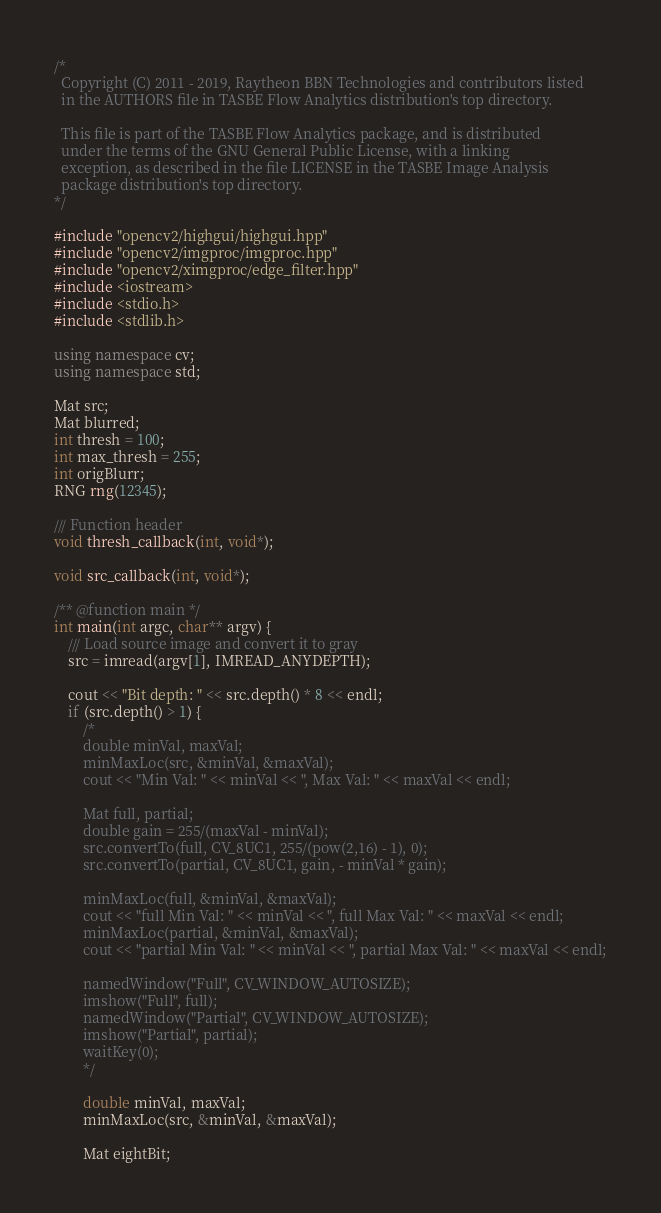<code> <loc_0><loc_0><loc_500><loc_500><_C++_>/*
  Copyright (C) 2011 - 2019, Raytheon BBN Technologies and contributors listed
  in the AUTHORS file in TASBE Flow Analytics distribution's top directory.

  This file is part of the TASBE Flow Analytics package, and is distributed
  under the terms of the GNU General Public License, with a linking
  exception, as described in the file LICENSE in the TASBE Image Analysis
  package distribution's top directory.
*/

#include "opencv2/highgui/highgui.hpp"
#include "opencv2/imgproc/imgproc.hpp"
#include "opencv2/ximgproc/edge_filter.hpp"
#include <iostream>
#include <stdio.h>
#include <stdlib.h>

using namespace cv;
using namespace std;

Mat src;
Mat blurred;
int thresh = 100;
int max_thresh = 255;
int origBlurr;
RNG rng(12345);

/// Function header
void thresh_callback(int, void*);

void src_callback(int, void*);

/** @function main */
int main(int argc, char** argv) {
	/// Load source image and convert it to gray
	src = imread(argv[1], IMREAD_ANYDEPTH);

	cout << "Bit depth: " << src.depth() * 8 << endl;
	if (src.depth() > 1) {
		/*
		double minVal, maxVal;
		minMaxLoc(src, &minVal, &maxVal);
		cout << "Min Val: " << minVal << ", Max Val: " << maxVal << endl;

		Mat full, partial;
		double gain = 255/(maxVal - minVal);
		src.convertTo(full, CV_8UC1, 255/(pow(2,16) - 1), 0);
		src.convertTo(partial, CV_8UC1, gain, - minVal * gain);

		minMaxLoc(full, &minVal, &maxVal);
		cout << "full Min Val: " << minVal << ", full Max Val: " << maxVal << endl;
		minMaxLoc(partial, &minVal, &maxVal);
		cout << "partial Min Val: " << minVal << ", partial Max Val: " << maxVal << endl;

		namedWindow("Full", CV_WINDOW_AUTOSIZE);
		imshow("Full", full);
		namedWindow("Partial", CV_WINDOW_AUTOSIZE);
		imshow("Partial", partial);
		waitKey(0);
		*/

		double minVal, maxVal;
		minMaxLoc(src, &minVal, &maxVal);

		Mat eightBit;</code> 